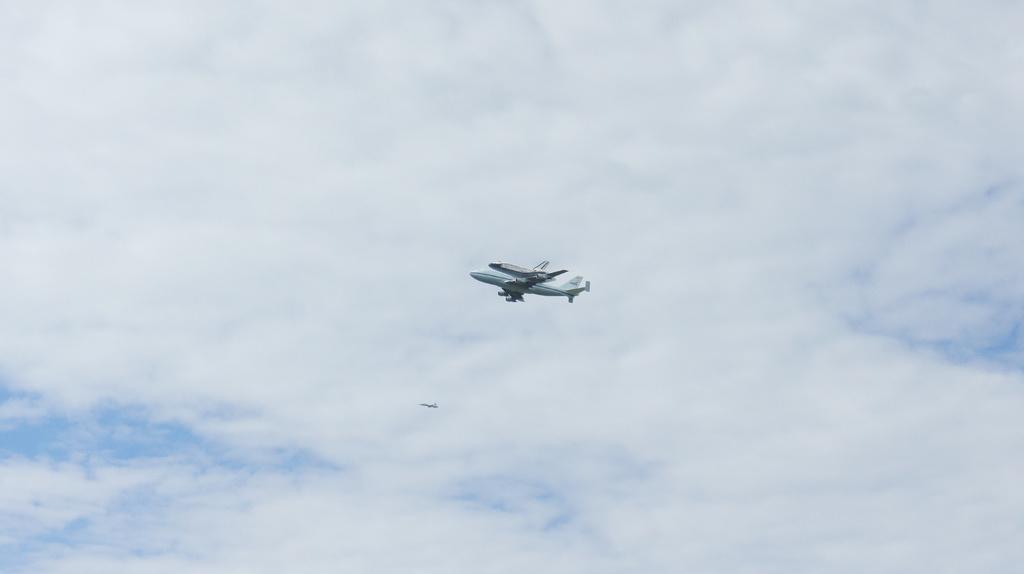Please provide a concise description of this image. In this picture there are aircrafts flying. At the top there is sky and there are clouds. 